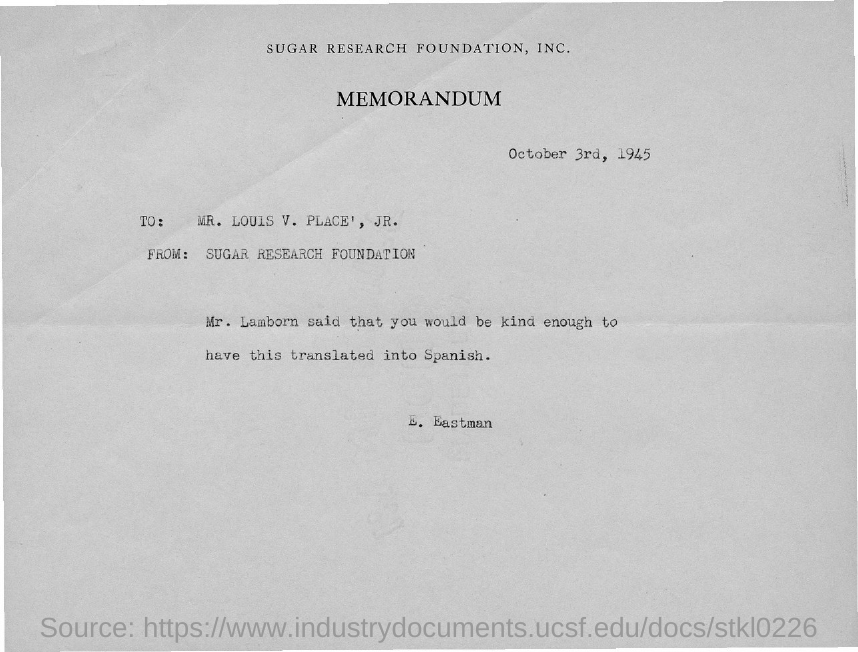Indicate a few pertinent items in this graphic. The document mentions Sugar Research Foundation, Inc. in its header. The addressee of this memorandum is Mr. Louis V. Place, Jr. The memorandum states that the date mentioned is October 3rd, 1945. The memorandum's sender is the Sugar Research Foundation. 